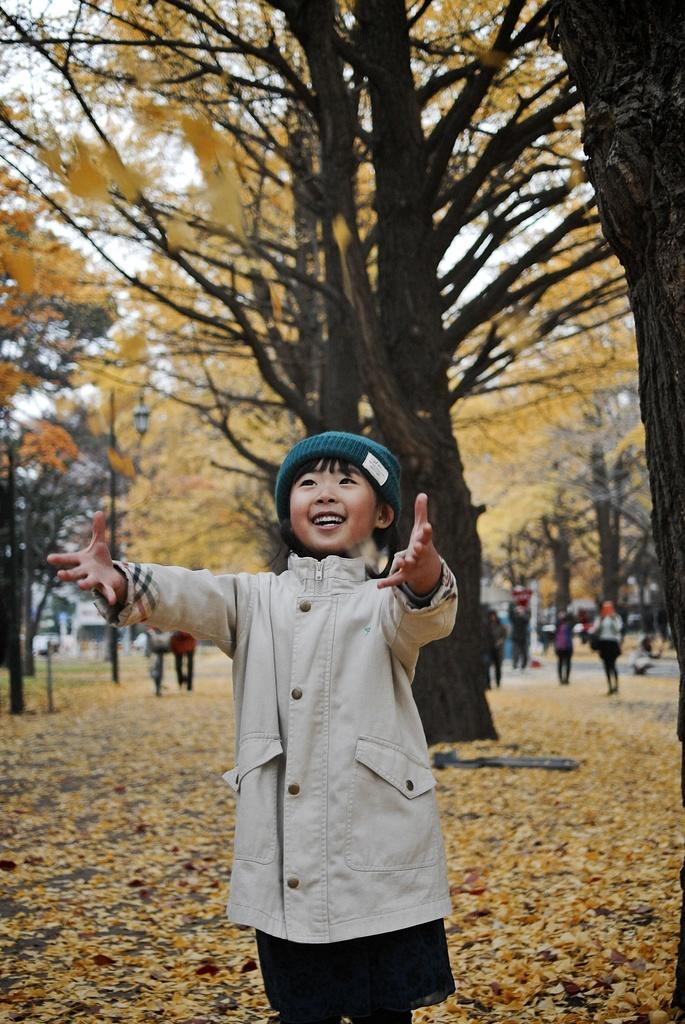Who is the main subject in the image? There is a small girl in the center of the image. What can be seen in the background of the image? There are flower trees and other people in the background of the image. Is the small girl in the image a fictional character from a spy novel? No, the small girl in the image is not a fictional character from a spy novel. The image appears to be a candid photograph of a real person in a real-life setting. 